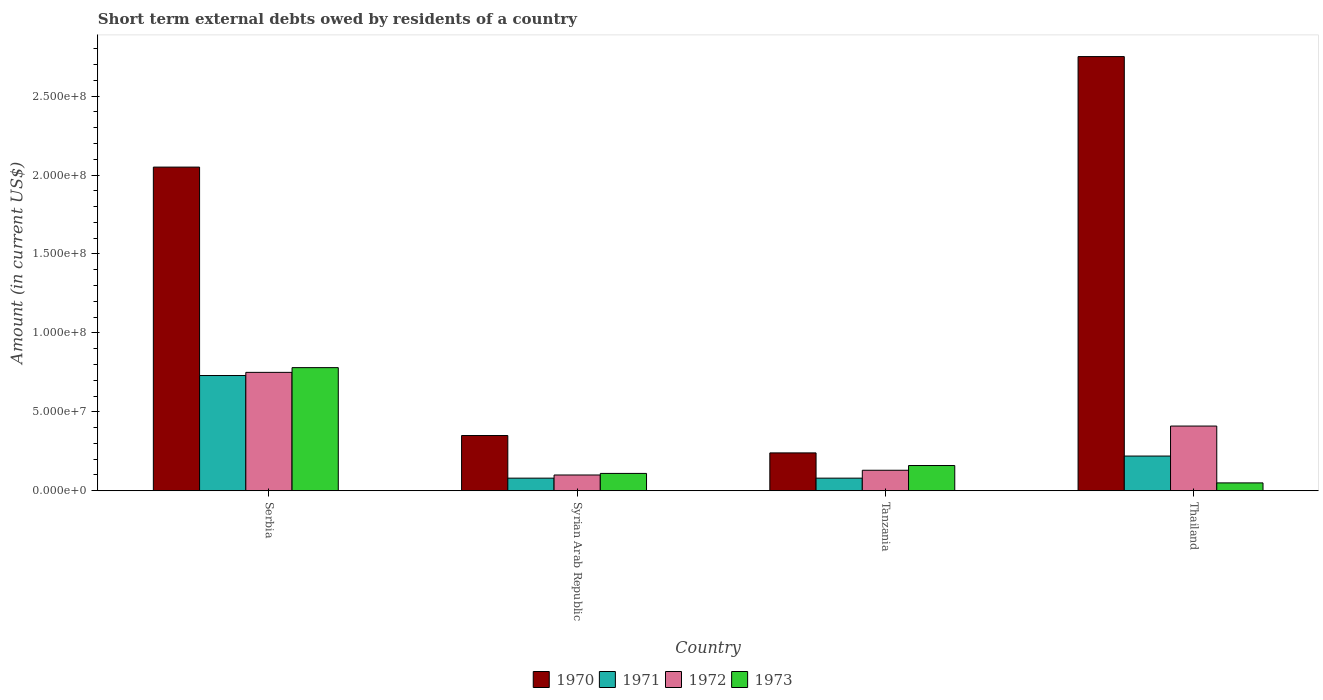How many different coloured bars are there?
Offer a very short reply. 4. How many groups of bars are there?
Ensure brevity in your answer.  4. Are the number of bars on each tick of the X-axis equal?
Provide a succinct answer. Yes. How many bars are there on the 1st tick from the left?
Offer a very short reply. 4. How many bars are there on the 2nd tick from the right?
Ensure brevity in your answer.  4. What is the label of the 1st group of bars from the left?
Provide a succinct answer. Serbia. In how many cases, is the number of bars for a given country not equal to the number of legend labels?
Your response must be concise. 0. What is the amount of short-term external debts owed by residents in 1973 in Tanzania?
Keep it short and to the point. 1.60e+07. Across all countries, what is the maximum amount of short-term external debts owed by residents in 1970?
Offer a very short reply. 2.75e+08. Across all countries, what is the minimum amount of short-term external debts owed by residents in 1970?
Make the answer very short. 2.40e+07. In which country was the amount of short-term external debts owed by residents in 1972 maximum?
Make the answer very short. Serbia. In which country was the amount of short-term external debts owed by residents in 1971 minimum?
Keep it short and to the point. Syrian Arab Republic. What is the total amount of short-term external debts owed by residents in 1970 in the graph?
Ensure brevity in your answer.  5.39e+08. What is the difference between the amount of short-term external debts owed by residents in 1973 in Tanzania and that in Thailand?
Provide a succinct answer. 1.10e+07. What is the difference between the amount of short-term external debts owed by residents in 1970 in Tanzania and the amount of short-term external debts owed by residents in 1971 in Serbia?
Your response must be concise. -4.90e+07. What is the average amount of short-term external debts owed by residents in 1971 per country?
Your answer should be compact. 2.78e+07. What is the difference between the amount of short-term external debts owed by residents of/in 1973 and amount of short-term external debts owed by residents of/in 1970 in Tanzania?
Your answer should be compact. -8.00e+06. What is the ratio of the amount of short-term external debts owed by residents in 1972 in Serbia to that in Thailand?
Offer a terse response. 1.83. Is the amount of short-term external debts owed by residents in 1971 in Serbia less than that in Tanzania?
Your response must be concise. No. What is the difference between the highest and the second highest amount of short-term external debts owed by residents in 1972?
Provide a succinct answer. 3.40e+07. What is the difference between the highest and the lowest amount of short-term external debts owed by residents in 1972?
Provide a succinct answer. 6.50e+07. Is the sum of the amount of short-term external debts owed by residents in 1970 in Serbia and Tanzania greater than the maximum amount of short-term external debts owed by residents in 1972 across all countries?
Make the answer very short. Yes. What is the difference between two consecutive major ticks on the Y-axis?
Offer a very short reply. 5.00e+07. Are the values on the major ticks of Y-axis written in scientific E-notation?
Provide a succinct answer. Yes. Does the graph contain grids?
Provide a short and direct response. No. Where does the legend appear in the graph?
Your response must be concise. Bottom center. How are the legend labels stacked?
Give a very brief answer. Horizontal. What is the title of the graph?
Make the answer very short. Short term external debts owed by residents of a country. What is the Amount (in current US$) of 1970 in Serbia?
Your answer should be compact. 2.05e+08. What is the Amount (in current US$) in 1971 in Serbia?
Provide a short and direct response. 7.30e+07. What is the Amount (in current US$) in 1972 in Serbia?
Your answer should be very brief. 7.50e+07. What is the Amount (in current US$) in 1973 in Serbia?
Keep it short and to the point. 7.80e+07. What is the Amount (in current US$) of 1970 in Syrian Arab Republic?
Offer a very short reply. 3.50e+07. What is the Amount (in current US$) in 1971 in Syrian Arab Republic?
Ensure brevity in your answer.  8.00e+06. What is the Amount (in current US$) of 1973 in Syrian Arab Republic?
Give a very brief answer. 1.10e+07. What is the Amount (in current US$) of 1970 in Tanzania?
Your answer should be very brief. 2.40e+07. What is the Amount (in current US$) of 1971 in Tanzania?
Give a very brief answer. 8.00e+06. What is the Amount (in current US$) of 1972 in Tanzania?
Provide a short and direct response. 1.30e+07. What is the Amount (in current US$) of 1973 in Tanzania?
Your answer should be compact. 1.60e+07. What is the Amount (in current US$) in 1970 in Thailand?
Make the answer very short. 2.75e+08. What is the Amount (in current US$) of 1971 in Thailand?
Keep it short and to the point. 2.20e+07. What is the Amount (in current US$) in 1972 in Thailand?
Your answer should be very brief. 4.10e+07. Across all countries, what is the maximum Amount (in current US$) in 1970?
Your response must be concise. 2.75e+08. Across all countries, what is the maximum Amount (in current US$) of 1971?
Give a very brief answer. 7.30e+07. Across all countries, what is the maximum Amount (in current US$) of 1972?
Make the answer very short. 7.50e+07. Across all countries, what is the maximum Amount (in current US$) of 1973?
Ensure brevity in your answer.  7.80e+07. Across all countries, what is the minimum Amount (in current US$) in 1970?
Offer a very short reply. 2.40e+07. Across all countries, what is the minimum Amount (in current US$) of 1973?
Offer a terse response. 5.00e+06. What is the total Amount (in current US$) of 1970 in the graph?
Give a very brief answer. 5.39e+08. What is the total Amount (in current US$) in 1971 in the graph?
Keep it short and to the point. 1.11e+08. What is the total Amount (in current US$) of 1972 in the graph?
Give a very brief answer. 1.39e+08. What is the total Amount (in current US$) in 1973 in the graph?
Your answer should be compact. 1.10e+08. What is the difference between the Amount (in current US$) of 1970 in Serbia and that in Syrian Arab Republic?
Ensure brevity in your answer.  1.70e+08. What is the difference between the Amount (in current US$) of 1971 in Serbia and that in Syrian Arab Republic?
Offer a terse response. 6.50e+07. What is the difference between the Amount (in current US$) of 1972 in Serbia and that in Syrian Arab Republic?
Offer a terse response. 6.50e+07. What is the difference between the Amount (in current US$) in 1973 in Serbia and that in Syrian Arab Republic?
Make the answer very short. 6.70e+07. What is the difference between the Amount (in current US$) in 1970 in Serbia and that in Tanzania?
Your answer should be very brief. 1.81e+08. What is the difference between the Amount (in current US$) in 1971 in Serbia and that in Tanzania?
Make the answer very short. 6.50e+07. What is the difference between the Amount (in current US$) in 1972 in Serbia and that in Tanzania?
Offer a very short reply. 6.20e+07. What is the difference between the Amount (in current US$) of 1973 in Serbia and that in Tanzania?
Provide a succinct answer. 6.20e+07. What is the difference between the Amount (in current US$) of 1970 in Serbia and that in Thailand?
Offer a very short reply. -7.00e+07. What is the difference between the Amount (in current US$) of 1971 in Serbia and that in Thailand?
Keep it short and to the point. 5.10e+07. What is the difference between the Amount (in current US$) of 1972 in Serbia and that in Thailand?
Your response must be concise. 3.40e+07. What is the difference between the Amount (in current US$) in 1973 in Serbia and that in Thailand?
Make the answer very short. 7.30e+07. What is the difference between the Amount (in current US$) in 1970 in Syrian Arab Republic and that in Tanzania?
Offer a very short reply. 1.10e+07. What is the difference between the Amount (in current US$) in 1971 in Syrian Arab Republic and that in Tanzania?
Your response must be concise. 0. What is the difference between the Amount (in current US$) in 1972 in Syrian Arab Republic and that in Tanzania?
Offer a terse response. -3.00e+06. What is the difference between the Amount (in current US$) in 1973 in Syrian Arab Republic and that in Tanzania?
Your answer should be compact. -5.00e+06. What is the difference between the Amount (in current US$) of 1970 in Syrian Arab Republic and that in Thailand?
Your answer should be compact. -2.40e+08. What is the difference between the Amount (in current US$) of 1971 in Syrian Arab Republic and that in Thailand?
Provide a succinct answer. -1.40e+07. What is the difference between the Amount (in current US$) in 1972 in Syrian Arab Republic and that in Thailand?
Offer a terse response. -3.10e+07. What is the difference between the Amount (in current US$) of 1973 in Syrian Arab Republic and that in Thailand?
Ensure brevity in your answer.  6.00e+06. What is the difference between the Amount (in current US$) of 1970 in Tanzania and that in Thailand?
Keep it short and to the point. -2.51e+08. What is the difference between the Amount (in current US$) in 1971 in Tanzania and that in Thailand?
Keep it short and to the point. -1.40e+07. What is the difference between the Amount (in current US$) of 1972 in Tanzania and that in Thailand?
Your response must be concise. -2.80e+07. What is the difference between the Amount (in current US$) in 1973 in Tanzania and that in Thailand?
Your answer should be very brief. 1.10e+07. What is the difference between the Amount (in current US$) of 1970 in Serbia and the Amount (in current US$) of 1971 in Syrian Arab Republic?
Make the answer very short. 1.97e+08. What is the difference between the Amount (in current US$) of 1970 in Serbia and the Amount (in current US$) of 1972 in Syrian Arab Republic?
Your answer should be very brief. 1.95e+08. What is the difference between the Amount (in current US$) in 1970 in Serbia and the Amount (in current US$) in 1973 in Syrian Arab Republic?
Provide a short and direct response. 1.94e+08. What is the difference between the Amount (in current US$) in 1971 in Serbia and the Amount (in current US$) in 1972 in Syrian Arab Republic?
Your answer should be compact. 6.30e+07. What is the difference between the Amount (in current US$) in 1971 in Serbia and the Amount (in current US$) in 1973 in Syrian Arab Republic?
Your answer should be compact. 6.20e+07. What is the difference between the Amount (in current US$) in 1972 in Serbia and the Amount (in current US$) in 1973 in Syrian Arab Republic?
Your response must be concise. 6.40e+07. What is the difference between the Amount (in current US$) of 1970 in Serbia and the Amount (in current US$) of 1971 in Tanzania?
Your answer should be very brief. 1.97e+08. What is the difference between the Amount (in current US$) of 1970 in Serbia and the Amount (in current US$) of 1972 in Tanzania?
Provide a succinct answer. 1.92e+08. What is the difference between the Amount (in current US$) in 1970 in Serbia and the Amount (in current US$) in 1973 in Tanzania?
Provide a succinct answer. 1.89e+08. What is the difference between the Amount (in current US$) of 1971 in Serbia and the Amount (in current US$) of 1972 in Tanzania?
Ensure brevity in your answer.  6.00e+07. What is the difference between the Amount (in current US$) of 1971 in Serbia and the Amount (in current US$) of 1973 in Tanzania?
Make the answer very short. 5.70e+07. What is the difference between the Amount (in current US$) of 1972 in Serbia and the Amount (in current US$) of 1973 in Tanzania?
Offer a terse response. 5.90e+07. What is the difference between the Amount (in current US$) in 1970 in Serbia and the Amount (in current US$) in 1971 in Thailand?
Offer a very short reply. 1.83e+08. What is the difference between the Amount (in current US$) in 1970 in Serbia and the Amount (in current US$) in 1972 in Thailand?
Provide a short and direct response. 1.64e+08. What is the difference between the Amount (in current US$) of 1970 in Serbia and the Amount (in current US$) of 1973 in Thailand?
Keep it short and to the point. 2.00e+08. What is the difference between the Amount (in current US$) in 1971 in Serbia and the Amount (in current US$) in 1972 in Thailand?
Offer a terse response. 3.20e+07. What is the difference between the Amount (in current US$) in 1971 in Serbia and the Amount (in current US$) in 1973 in Thailand?
Make the answer very short. 6.80e+07. What is the difference between the Amount (in current US$) of 1972 in Serbia and the Amount (in current US$) of 1973 in Thailand?
Provide a succinct answer. 7.00e+07. What is the difference between the Amount (in current US$) in 1970 in Syrian Arab Republic and the Amount (in current US$) in 1971 in Tanzania?
Your answer should be very brief. 2.70e+07. What is the difference between the Amount (in current US$) of 1970 in Syrian Arab Republic and the Amount (in current US$) of 1972 in Tanzania?
Your response must be concise. 2.20e+07. What is the difference between the Amount (in current US$) in 1970 in Syrian Arab Republic and the Amount (in current US$) in 1973 in Tanzania?
Provide a succinct answer. 1.90e+07. What is the difference between the Amount (in current US$) of 1971 in Syrian Arab Republic and the Amount (in current US$) of 1972 in Tanzania?
Make the answer very short. -5.00e+06. What is the difference between the Amount (in current US$) in 1971 in Syrian Arab Republic and the Amount (in current US$) in 1973 in Tanzania?
Your response must be concise. -8.00e+06. What is the difference between the Amount (in current US$) in 1972 in Syrian Arab Republic and the Amount (in current US$) in 1973 in Tanzania?
Your answer should be very brief. -6.00e+06. What is the difference between the Amount (in current US$) of 1970 in Syrian Arab Republic and the Amount (in current US$) of 1971 in Thailand?
Keep it short and to the point. 1.30e+07. What is the difference between the Amount (in current US$) in 1970 in Syrian Arab Republic and the Amount (in current US$) in 1972 in Thailand?
Your response must be concise. -6.00e+06. What is the difference between the Amount (in current US$) of 1970 in Syrian Arab Republic and the Amount (in current US$) of 1973 in Thailand?
Your answer should be very brief. 3.00e+07. What is the difference between the Amount (in current US$) in 1971 in Syrian Arab Republic and the Amount (in current US$) in 1972 in Thailand?
Provide a succinct answer. -3.30e+07. What is the difference between the Amount (in current US$) in 1970 in Tanzania and the Amount (in current US$) in 1972 in Thailand?
Provide a short and direct response. -1.70e+07. What is the difference between the Amount (in current US$) in 1970 in Tanzania and the Amount (in current US$) in 1973 in Thailand?
Provide a short and direct response. 1.90e+07. What is the difference between the Amount (in current US$) of 1971 in Tanzania and the Amount (in current US$) of 1972 in Thailand?
Ensure brevity in your answer.  -3.30e+07. What is the difference between the Amount (in current US$) of 1971 in Tanzania and the Amount (in current US$) of 1973 in Thailand?
Your answer should be compact. 3.00e+06. What is the difference between the Amount (in current US$) in 1972 in Tanzania and the Amount (in current US$) in 1973 in Thailand?
Offer a very short reply. 8.00e+06. What is the average Amount (in current US$) in 1970 per country?
Give a very brief answer. 1.35e+08. What is the average Amount (in current US$) of 1971 per country?
Your answer should be very brief. 2.78e+07. What is the average Amount (in current US$) of 1972 per country?
Your answer should be compact. 3.48e+07. What is the average Amount (in current US$) of 1973 per country?
Provide a succinct answer. 2.75e+07. What is the difference between the Amount (in current US$) of 1970 and Amount (in current US$) of 1971 in Serbia?
Provide a short and direct response. 1.32e+08. What is the difference between the Amount (in current US$) of 1970 and Amount (in current US$) of 1972 in Serbia?
Offer a terse response. 1.30e+08. What is the difference between the Amount (in current US$) of 1970 and Amount (in current US$) of 1973 in Serbia?
Make the answer very short. 1.27e+08. What is the difference between the Amount (in current US$) of 1971 and Amount (in current US$) of 1972 in Serbia?
Your answer should be very brief. -2.00e+06. What is the difference between the Amount (in current US$) of 1971 and Amount (in current US$) of 1973 in Serbia?
Offer a terse response. -5.00e+06. What is the difference between the Amount (in current US$) in 1970 and Amount (in current US$) in 1971 in Syrian Arab Republic?
Your response must be concise. 2.70e+07. What is the difference between the Amount (in current US$) of 1970 and Amount (in current US$) of 1972 in Syrian Arab Republic?
Ensure brevity in your answer.  2.50e+07. What is the difference between the Amount (in current US$) of 1970 and Amount (in current US$) of 1973 in Syrian Arab Republic?
Your response must be concise. 2.40e+07. What is the difference between the Amount (in current US$) in 1971 and Amount (in current US$) in 1973 in Syrian Arab Republic?
Your answer should be very brief. -3.00e+06. What is the difference between the Amount (in current US$) in 1970 and Amount (in current US$) in 1971 in Tanzania?
Your answer should be compact. 1.60e+07. What is the difference between the Amount (in current US$) of 1970 and Amount (in current US$) of 1972 in Tanzania?
Your answer should be very brief. 1.10e+07. What is the difference between the Amount (in current US$) in 1970 and Amount (in current US$) in 1973 in Tanzania?
Provide a succinct answer. 8.00e+06. What is the difference between the Amount (in current US$) in 1971 and Amount (in current US$) in 1972 in Tanzania?
Give a very brief answer. -5.00e+06. What is the difference between the Amount (in current US$) of 1971 and Amount (in current US$) of 1973 in Tanzania?
Offer a very short reply. -8.00e+06. What is the difference between the Amount (in current US$) of 1972 and Amount (in current US$) of 1973 in Tanzania?
Provide a short and direct response. -3.00e+06. What is the difference between the Amount (in current US$) of 1970 and Amount (in current US$) of 1971 in Thailand?
Make the answer very short. 2.53e+08. What is the difference between the Amount (in current US$) of 1970 and Amount (in current US$) of 1972 in Thailand?
Your answer should be compact. 2.34e+08. What is the difference between the Amount (in current US$) of 1970 and Amount (in current US$) of 1973 in Thailand?
Offer a terse response. 2.70e+08. What is the difference between the Amount (in current US$) in 1971 and Amount (in current US$) in 1972 in Thailand?
Keep it short and to the point. -1.90e+07. What is the difference between the Amount (in current US$) in 1971 and Amount (in current US$) in 1973 in Thailand?
Offer a terse response. 1.70e+07. What is the difference between the Amount (in current US$) of 1972 and Amount (in current US$) of 1973 in Thailand?
Your response must be concise. 3.60e+07. What is the ratio of the Amount (in current US$) in 1970 in Serbia to that in Syrian Arab Republic?
Give a very brief answer. 5.86. What is the ratio of the Amount (in current US$) of 1971 in Serbia to that in Syrian Arab Republic?
Make the answer very short. 9.12. What is the ratio of the Amount (in current US$) of 1972 in Serbia to that in Syrian Arab Republic?
Make the answer very short. 7.5. What is the ratio of the Amount (in current US$) of 1973 in Serbia to that in Syrian Arab Republic?
Ensure brevity in your answer.  7.09. What is the ratio of the Amount (in current US$) of 1970 in Serbia to that in Tanzania?
Give a very brief answer. 8.54. What is the ratio of the Amount (in current US$) of 1971 in Serbia to that in Tanzania?
Your response must be concise. 9.12. What is the ratio of the Amount (in current US$) in 1972 in Serbia to that in Tanzania?
Make the answer very short. 5.77. What is the ratio of the Amount (in current US$) of 1973 in Serbia to that in Tanzania?
Keep it short and to the point. 4.88. What is the ratio of the Amount (in current US$) of 1970 in Serbia to that in Thailand?
Offer a very short reply. 0.75. What is the ratio of the Amount (in current US$) in 1971 in Serbia to that in Thailand?
Provide a short and direct response. 3.32. What is the ratio of the Amount (in current US$) in 1972 in Serbia to that in Thailand?
Provide a succinct answer. 1.83. What is the ratio of the Amount (in current US$) in 1973 in Serbia to that in Thailand?
Provide a succinct answer. 15.6. What is the ratio of the Amount (in current US$) in 1970 in Syrian Arab Republic to that in Tanzania?
Give a very brief answer. 1.46. What is the ratio of the Amount (in current US$) in 1972 in Syrian Arab Republic to that in Tanzania?
Your answer should be compact. 0.77. What is the ratio of the Amount (in current US$) of 1973 in Syrian Arab Republic to that in Tanzania?
Make the answer very short. 0.69. What is the ratio of the Amount (in current US$) of 1970 in Syrian Arab Republic to that in Thailand?
Keep it short and to the point. 0.13. What is the ratio of the Amount (in current US$) of 1971 in Syrian Arab Republic to that in Thailand?
Your response must be concise. 0.36. What is the ratio of the Amount (in current US$) of 1972 in Syrian Arab Republic to that in Thailand?
Your answer should be compact. 0.24. What is the ratio of the Amount (in current US$) of 1970 in Tanzania to that in Thailand?
Provide a succinct answer. 0.09. What is the ratio of the Amount (in current US$) of 1971 in Tanzania to that in Thailand?
Your answer should be very brief. 0.36. What is the ratio of the Amount (in current US$) in 1972 in Tanzania to that in Thailand?
Give a very brief answer. 0.32. What is the difference between the highest and the second highest Amount (in current US$) of 1970?
Ensure brevity in your answer.  7.00e+07. What is the difference between the highest and the second highest Amount (in current US$) in 1971?
Provide a short and direct response. 5.10e+07. What is the difference between the highest and the second highest Amount (in current US$) of 1972?
Your response must be concise. 3.40e+07. What is the difference between the highest and the second highest Amount (in current US$) of 1973?
Offer a terse response. 6.20e+07. What is the difference between the highest and the lowest Amount (in current US$) in 1970?
Make the answer very short. 2.51e+08. What is the difference between the highest and the lowest Amount (in current US$) in 1971?
Your answer should be very brief. 6.50e+07. What is the difference between the highest and the lowest Amount (in current US$) of 1972?
Provide a short and direct response. 6.50e+07. What is the difference between the highest and the lowest Amount (in current US$) of 1973?
Make the answer very short. 7.30e+07. 